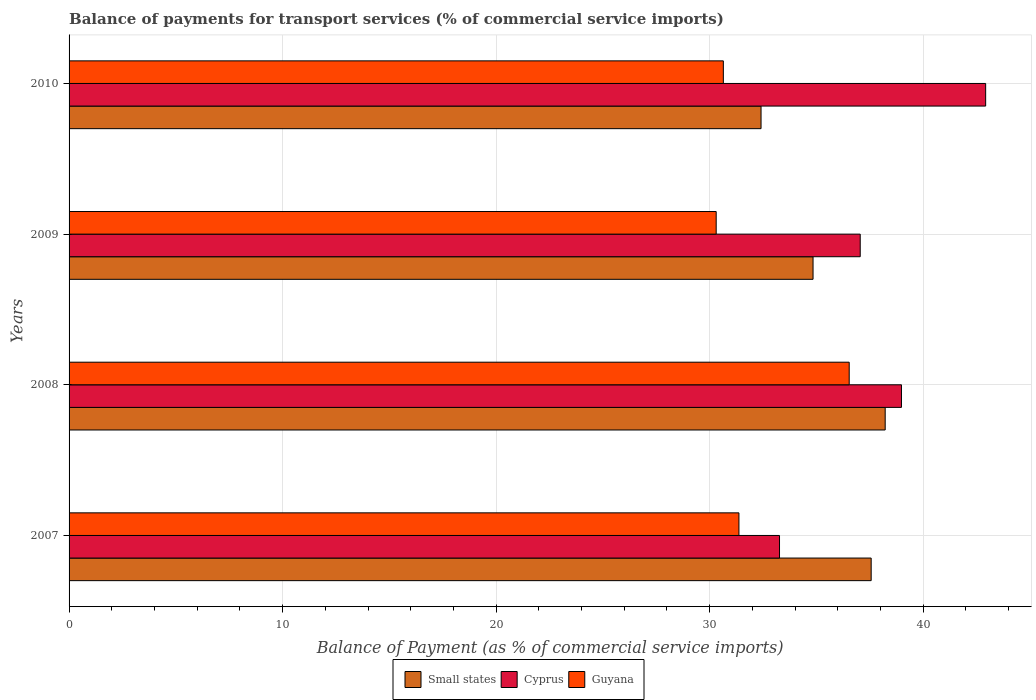How many different coloured bars are there?
Your response must be concise. 3. How many bars are there on the 1st tick from the top?
Offer a terse response. 3. In how many cases, is the number of bars for a given year not equal to the number of legend labels?
Offer a terse response. 0. What is the balance of payments for transport services in Small states in 2008?
Offer a very short reply. 38.22. Across all years, what is the maximum balance of payments for transport services in Small states?
Provide a short and direct response. 38.22. Across all years, what is the minimum balance of payments for transport services in Guyana?
Your answer should be compact. 30.31. In which year was the balance of payments for transport services in Guyana maximum?
Provide a short and direct response. 2008. What is the total balance of payments for transport services in Small states in the graph?
Give a very brief answer. 143.03. What is the difference between the balance of payments for transport services in Guyana in 2007 and that in 2010?
Give a very brief answer. 0.73. What is the difference between the balance of payments for transport services in Small states in 2008 and the balance of payments for transport services in Guyana in 2007?
Offer a very short reply. 6.85. What is the average balance of payments for transport services in Guyana per year?
Offer a very short reply. 32.21. In the year 2009, what is the difference between the balance of payments for transport services in Cyprus and balance of payments for transport services in Small states?
Your answer should be compact. 2.21. In how many years, is the balance of payments for transport services in Cyprus greater than 8 %?
Keep it short and to the point. 4. What is the ratio of the balance of payments for transport services in Cyprus in 2009 to that in 2010?
Offer a very short reply. 0.86. Is the balance of payments for transport services in Cyprus in 2009 less than that in 2010?
Offer a very short reply. Yes. Is the difference between the balance of payments for transport services in Cyprus in 2008 and 2009 greater than the difference between the balance of payments for transport services in Small states in 2008 and 2009?
Your answer should be compact. No. What is the difference between the highest and the second highest balance of payments for transport services in Small states?
Keep it short and to the point. 0.66. What is the difference between the highest and the lowest balance of payments for transport services in Guyana?
Ensure brevity in your answer.  6.23. In how many years, is the balance of payments for transport services in Cyprus greater than the average balance of payments for transport services in Cyprus taken over all years?
Provide a short and direct response. 2. What does the 3rd bar from the top in 2008 represents?
Make the answer very short. Small states. What does the 2nd bar from the bottom in 2009 represents?
Offer a very short reply. Cyprus. Are all the bars in the graph horizontal?
Keep it short and to the point. Yes. How are the legend labels stacked?
Offer a very short reply. Horizontal. What is the title of the graph?
Offer a terse response. Balance of payments for transport services (% of commercial service imports). Does "Mexico" appear as one of the legend labels in the graph?
Ensure brevity in your answer.  No. What is the label or title of the X-axis?
Offer a terse response. Balance of Payment (as % of commercial service imports). What is the label or title of the Y-axis?
Provide a succinct answer. Years. What is the Balance of Payment (as % of commercial service imports) in Small states in 2007?
Provide a succinct answer. 37.56. What is the Balance of Payment (as % of commercial service imports) of Cyprus in 2007?
Provide a short and direct response. 33.27. What is the Balance of Payment (as % of commercial service imports) of Guyana in 2007?
Give a very brief answer. 31.37. What is the Balance of Payment (as % of commercial service imports) in Small states in 2008?
Make the answer very short. 38.22. What is the Balance of Payment (as % of commercial service imports) of Cyprus in 2008?
Ensure brevity in your answer.  38.98. What is the Balance of Payment (as % of commercial service imports) in Guyana in 2008?
Your answer should be compact. 36.53. What is the Balance of Payment (as % of commercial service imports) of Small states in 2009?
Provide a succinct answer. 34.84. What is the Balance of Payment (as % of commercial service imports) in Cyprus in 2009?
Offer a terse response. 37.05. What is the Balance of Payment (as % of commercial service imports) in Guyana in 2009?
Offer a terse response. 30.31. What is the Balance of Payment (as % of commercial service imports) of Small states in 2010?
Ensure brevity in your answer.  32.41. What is the Balance of Payment (as % of commercial service imports) of Cyprus in 2010?
Your answer should be compact. 42.93. What is the Balance of Payment (as % of commercial service imports) in Guyana in 2010?
Offer a terse response. 30.64. Across all years, what is the maximum Balance of Payment (as % of commercial service imports) of Small states?
Offer a terse response. 38.22. Across all years, what is the maximum Balance of Payment (as % of commercial service imports) in Cyprus?
Provide a succinct answer. 42.93. Across all years, what is the maximum Balance of Payment (as % of commercial service imports) of Guyana?
Provide a succinct answer. 36.53. Across all years, what is the minimum Balance of Payment (as % of commercial service imports) of Small states?
Your response must be concise. 32.41. Across all years, what is the minimum Balance of Payment (as % of commercial service imports) in Cyprus?
Offer a terse response. 33.27. Across all years, what is the minimum Balance of Payment (as % of commercial service imports) in Guyana?
Keep it short and to the point. 30.31. What is the total Balance of Payment (as % of commercial service imports) in Small states in the graph?
Ensure brevity in your answer.  143.03. What is the total Balance of Payment (as % of commercial service imports) of Cyprus in the graph?
Offer a very short reply. 152.23. What is the total Balance of Payment (as % of commercial service imports) in Guyana in the graph?
Provide a succinct answer. 128.85. What is the difference between the Balance of Payment (as % of commercial service imports) of Small states in 2007 and that in 2008?
Make the answer very short. -0.66. What is the difference between the Balance of Payment (as % of commercial service imports) of Cyprus in 2007 and that in 2008?
Your response must be concise. -5.71. What is the difference between the Balance of Payment (as % of commercial service imports) in Guyana in 2007 and that in 2008?
Your response must be concise. -5.16. What is the difference between the Balance of Payment (as % of commercial service imports) of Small states in 2007 and that in 2009?
Your answer should be very brief. 2.72. What is the difference between the Balance of Payment (as % of commercial service imports) in Cyprus in 2007 and that in 2009?
Ensure brevity in your answer.  -3.78. What is the difference between the Balance of Payment (as % of commercial service imports) in Guyana in 2007 and that in 2009?
Provide a succinct answer. 1.07. What is the difference between the Balance of Payment (as % of commercial service imports) of Small states in 2007 and that in 2010?
Provide a short and direct response. 5.16. What is the difference between the Balance of Payment (as % of commercial service imports) of Cyprus in 2007 and that in 2010?
Provide a succinct answer. -9.65. What is the difference between the Balance of Payment (as % of commercial service imports) in Guyana in 2007 and that in 2010?
Offer a terse response. 0.73. What is the difference between the Balance of Payment (as % of commercial service imports) in Small states in 2008 and that in 2009?
Offer a terse response. 3.38. What is the difference between the Balance of Payment (as % of commercial service imports) in Cyprus in 2008 and that in 2009?
Your answer should be very brief. 1.93. What is the difference between the Balance of Payment (as % of commercial service imports) of Guyana in 2008 and that in 2009?
Provide a succinct answer. 6.23. What is the difference between the Balance of Payment (as % of commercial service imports) of Small states in 2008 and that in 2010?
Keep it short and to the point. 5.81. What is the difference between the Balance of Payment (as % of commercial service imports) of Cyprus in 2008 and that in 2010?
Provide a succinct answer. -3.94. What is the difference between the Balance of Payment (as % of commercial service imports) in Guyana in 2008 and that in 2010?
Your answer should be very brief. 5.89. What is the difference between the Balance of Payment (as % of commercial service imports) in Small states in 2009 and that in 2010?
Provide a succinct answer. 2.44. What is the difference between the Balance of Payment (as % of commercial service imports) of Cyprus in 2009 and that in 2010?
Your response must be concise. -5.87. What is the difference between the Balance of Payment (as % of commercial service imports) in Guyana in 2009 and that in 2010?
Provide a short and direct response. -0.33. What is the difference between the Balance of Payment (as % of commercial service imports) of Small states in 2007 and the Balance of Payment (as % of commercial service imports) of Cyprus in 2008?
Give a very brief answer. -1.42. What is the difference between the Balance of Payment (as % of commercial service imports) in Small states in 2007 and the Balance of Payment (as % of commercial service imports) in Guyana in 2008?
Offer a very short reply. 1.03. What is the difference between the Balance of Payment (as % of commercial service imports) of Cyprus in 2007 and the Balance of Payment (as % of commercial service imports) of Guyana in 2008?
Keep it short and to the point. -3.26. What is the difference between the Balance of Payment (as % of commercial service imports) of Small states in 2007 and the Balance of Payment (as % of commercial service imports) of Cyprus in 2009?
Provide a short and direct response. 0.51. What is the difference between the Balance of Payment (as % of commercial service imports) of Small states in 2007 and the Balance of Payment (as % of commercial service imports) of Guyana in 2009?
Your answer should be compact. 7.26. What is the difference between the Balance of Payment (as % of commercial service imports) of Cyprus in 2007 and the Balance of Payment (as % of commercial service imports) of Guyana in 2009?
Offer a terse response. 2.97. What is the difference between the Balance of Payment (as % of commercial service imports) of Small states in 2007 and the Balance of Payment (as % of commercial service imports) of Cyprus in 2010?
Give a very brief answer. -5.36. What is the difference between the Balance of Payment (as % of commercial service imports) in Small states in 2007 and the Balance of Payment (as % of commercial service imports) in Guyana in 2010?
Your answer should be compact. 6.92. What is the difference between the Balance of Payment (as % of commercial service imports) of Cyprus in 2007 and the Balance of Payment (as % of commercial service imports) of Guyana in 2010?
Make the answer very short. 2.63. What is the difference between the Balance of Payment (as % of commercial service imports) of Small states in 2008 and the Balance of Payment (as % of commercial service imports) of Cyprus in 2009?
Your answer should be very brief. 1.17. What is the difference between the Balance of Payment (as % of commercial service imports) in Small states in 2008 and the Balance of Payment (as % of commercial service imports) in Guyana in 2009?
Give a very brief answer. 7.91. What is the difference between the Balance of Payment (as % of commercial service imports) of Cyprus in 2008 and the Balance of Payment (as % of commercial service imports) of Guyana in 2009?
Make the answer very short. 8.68. What is the difference between the Balance of Payment (as % of commercial service imports) of Small states in 2008 and the Balance of Payment (as % of commercial service imports) of Cyprus in 2010?
Ensure brevity in your answer.  -4.71. What is the difference between the Balance of Payment (as % of commercial service imports) of Small states in 2008 and the Balance of Payment (as % of commercial service imports) of Guyana in 2010?
Offer a terse response. 7.58. What is the difference between the Balance of Payment (as % of commercial service imports) in Cyprus in 2008 and the Balance of Payment (as % of commercial service imports) in Guyana in 2010?
Offer a very short reply. 8.34. What is the difference between the Balance of Payment (as % of commercial service imports) in Small states in 2009 and the Balance of Payment (as % of commercial service imports) in Cyprus in 2010?
Give a very brief answer. -8.08. What is the difference between the Balance of Payment (as % of commercial service imports) in Small states in 2009 and the Balance of Payment (as % of commercial service imports) in Guyana in 2010?
Offer a very short reply. 4.2. What is the difference between the Balance of Payment (as % of commercial service imports) in Cyprus in 2009 and the Balance of Payment (as % of commercial service imports) in Guyana in 2010?
Keep it short and to the point. 6.41. What is the average Balance of Payment (as % of commercial service imports) of Small states per year?
Provide a short and direct response. 35.76. What is the average Balance of Payment (as % of commercial service imports) of Cyprus per year?
Your answer should be compact. 38.06. What is the average Balance of Payment (as % of commercial service imports) in Guyana per year?
Keep it short and to the point. 32.21. In the year 2007, what is the difference between the Balance of Payment (as % of commercial service imports) of Small states and Balance of Payment (as % of commercial service imports) of Cyprus?
Your answer should be compact. 4.29. In the year 2007, what is the difference between the Balance of Payment (as % of commercial service imports) in Small states and Balance of Payment (as % of commercial service imports) in Guyana?
Your answer should be very brief. 6.19. In the year 2007, what is the difference between the Balance of Payment (as % of commercial service imports) of Cyprus and Balance of Payment (as % of commercial service imports) of Guyana?
Offer a terse response. 1.9. In the year 2008, what is the difference between the Balance of Payment (as % of commercial service imports) of Small states and Balance of Payment (as % of commercial service imports) of Cyprus?
Provide a succinct answer. -0.76. In the year 2008, what is the difference between the Balance of Payment (as % of commercial service imports) of Small states and Balance of Payment (as % of commercial service imports) of Guyana?
Your answer should be compact. 1.69. In the year 2008, what is the difference between the Balance of Payment (as % of commercial service imports) in Cyprus and Balance of Payment (as % of commercial service imports) in Guyana?
Your answer should be very brief. 2.45. In the year 2009, what is the difference between the Balance of Payment (as % of commercial service imports) of Small states and Balance of Payment (as % of commercial service imports) of Cyprus?
Your answer should be compact. -2.21. In the year 2009, what is the difference between the Balance of Payment (as % of commercial service imports) of Small states and Balance of Payment (as % of commercial service imports) of Guyana?
Your answer should be very brief. 4.54. In the year 2009, what is the difference between the Balance of Payment (as % of commercial service imports) in Cyprus and Balance of Payment (as % of commercial service imports) in Guyana?
Offer a terse response. 6.75. In the year 2010, what is the difference between the Balance of Payment (as % of commercial service imports) in Small states and Balance of Payment (as % of commercial service imports) in Cyprus?
Offer a very short reply. -10.52. In the year 2010, what is the difference between the Balance of Payment (as % of commercial service imports) in Small states and Balance of Payment (as % of commercial service imports) in Guyana?
Keep it short and to the point. 1.77. In the year 2010, what is the difference between the Balance of Payment (as % of commercial service imports) in Cyprus and Balance of Payment (as % of commercial service imports) in Guyana?
Offer a terse response. 12.29. What is the ratio of the Balance of Payment (as % of commercial service imports) of Small states in 2007 to that in 2008?
Offer a terse response. 0.98. What is the ratio of the Balance of Payment (as % of commercial service imports) in Cyprus in 2007 to that in 2008?
Make the answer very short. 0.85. What is the ratio of the Balance of Payment (as % of commercial service imports) in Guyana in 2007 to that in 2008?
Provide a succinct answer. 0.86. What is the ratio of the Balance of Payment (as % of commercial service imports) in Small states in 2007 to that in 2009?
Make the answer very short. 1.08. What is the ratio of the Balance of Payment (as % of commercial service imports) in Cyprus in 2007 to that in 2009?
Provide a short and direct response. 0.9. What is the ratio of the Balance of Payment (as % of commercial service imports) in Guyana in 2007 to that in 2009?
Your answer should be compact. 1.04. What is the ratio of the Balance of Payment (as % of commercial service imports) of Small states in 2007 to that in 2010?
Your answer should be very brief. 1.16. What is the ratio of the Balance of Payment (as % of commercial service imports) in Cyprus in 2007 to that in 2010?
Provide a succinct answer. 0.78. What is the ratio of the Balance of Payment (as % of commercial service imports) in Guyana in 2007 to that in 2010?
Ensure brevity in your answer.  1.02. What is the ratio of the Balance of Payment (as % of commercial service imports) of Small states in 2008 to that in 2009?
Keep it short and to the point. 1.1. What is the ratio of the Balance of Payment (as % of commercial service imports) of Cyprus in 2008 to that in 2009?
Offer a very short reply. 1.05. What is the ratio of the Balance of Payment (as % of commercial service imports) in Guyana in 2008 to that in 2009?
Give a very brief answer. 1.21. What is the ratio of the Balance of Payment (as % of commercial service imports) of Small states in 2008 to that in 2010?
Offer a terse response. 1.18. What is the ratio of the Balance of Payment (as % of commercial service imports) in Cyprus in 2008 to that in 2010?
Keep it short and to the point. 0.91. What is the ratio of the Balance of Payment (as % of commercial service imports) in Guyana in 2008 to that in 2010?
Provide a succinct answer. 1.19. What is the ratio of the Balance of Payment (as % of commercial service imports) of Small states in 2009 to that in 2010?
Your response must be concise. 1.08. What is the ratio of the Balance of Payment (as % of commercial service imports) in Cyprus in 2009 to that in 2010?
Keep it short and to the point. 0.86. What is the difference between the highest and the second highest Balance of Payment (as % of commercial service imports) in Small states?
Give a very brief answer. 0.66. What is the difference between the highest and the second highest Balance of Payment (as % of commercial service imports) of Cyprus?
Offer a very short reply. 3.94. What is the difference between the highest and the second highest Balance of Payment (as % of commercial service imports) in Guyana?
Your response must be concise. 5.16. What is the difference between the highest and the lowest Balance of Payment (as % of commercial service imports) of Small states?
Provide a succinct answer. 5.81. What is the difference between the highest and the lowest Balance of Payment (as % of commercial service imports) of Cyprus?
Offer a very short reply. 9.65. What is the difference between the highest and the lowest Balance of Payment (as % of commercial service imports) of Guyana?
Keep it short and to the point. 6.23. 